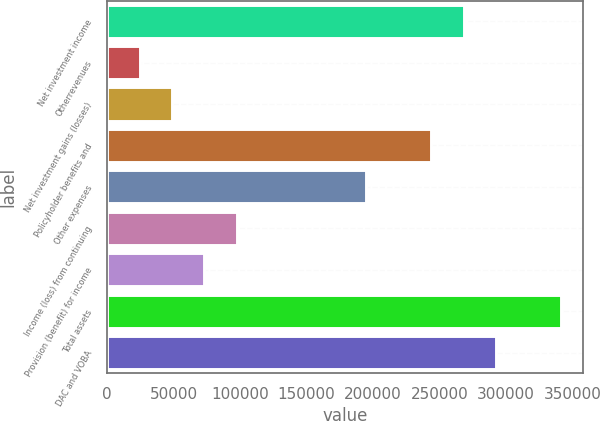Convert chart to OTSL. <chart><loc_0><loc_0><loc_500><loc_500><bar_chart><fcel>Net investment income<fcel>Otherrevenues<fcel>Net investment gains (losses)<fcel>Policyholder benefits and<fcel>Other expenses<fcel>Income (loss) from continuing<fcel>Provision (benefit) for income<fcel>Total assets<fcel>DAC and VOBA<nl><fcel>267959<fcel>24405.4<fcel>48760.8<fcel>243604<fcel>194893<fcel>97471.6<fcel>73116.2<fcel>341026<fcel>292315<nl></chart> 